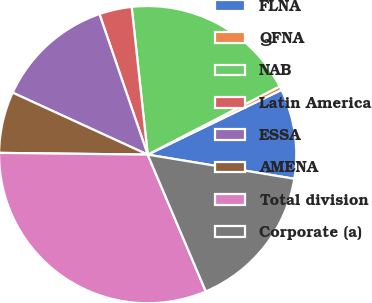<chart> <loc_0><loc_0><loc_500><loc_500><pie_chart><fcel>FLNA<fcel>QFNA<fcel>NAB<fcel>Latin America<fcel>ESSA<fcel>AMENA<fcel>Total division<fcel>Corporate (a)<nl><fcel>9.77%<fcel>0.43%<fcel>19.12%<fcel>3.54%<fcel>12.89%<fcel>6.66%<fcel>31.58%<fcel>16.01%<nl></chart> 